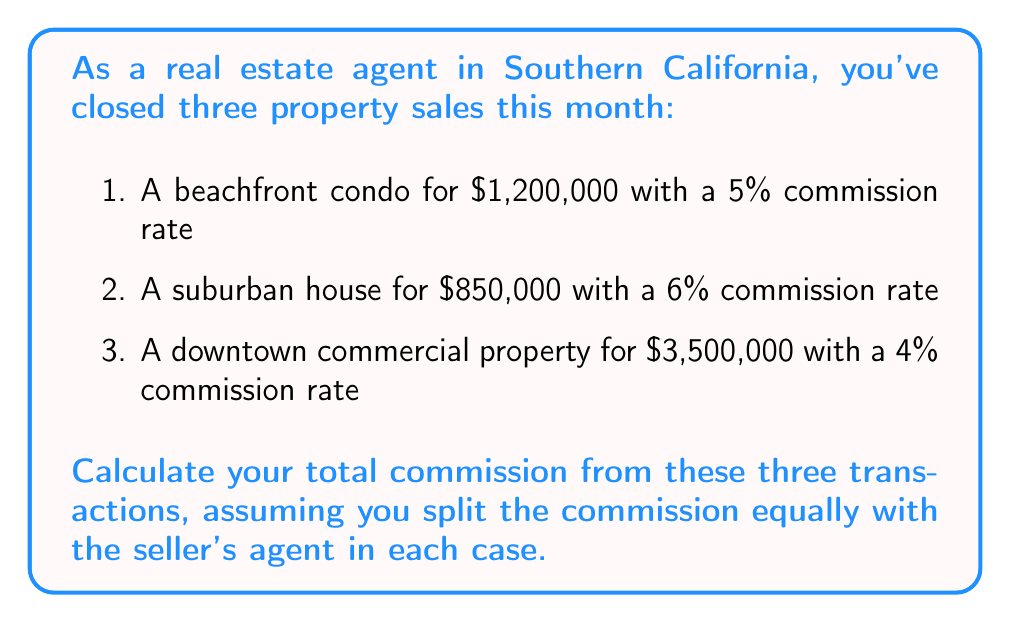Could you help me with this problem? Let's calculate the commission for each property sale:

1. Beachfront condo:
   Total commission: $1,200,000 \times 5\% = $60,000
   Your share: $60,000 \div 2 = $30,000

2. Suburban house:
   Total commission: $850,000 \times 6\% = $51,000
   Your share: $51,000 \div 2 = $25,500

3. Downtown commercial property:
   Total commission: $3,500,000 \times 4\% = $140,000
   Your share: $140,000 \div 2 = $70,000

Now, let's sum up your share of the commissions:

$$\text{Total commission} = $30,000 + $25,500 + $70,000 = $125,500$$
Answer: $125,500 